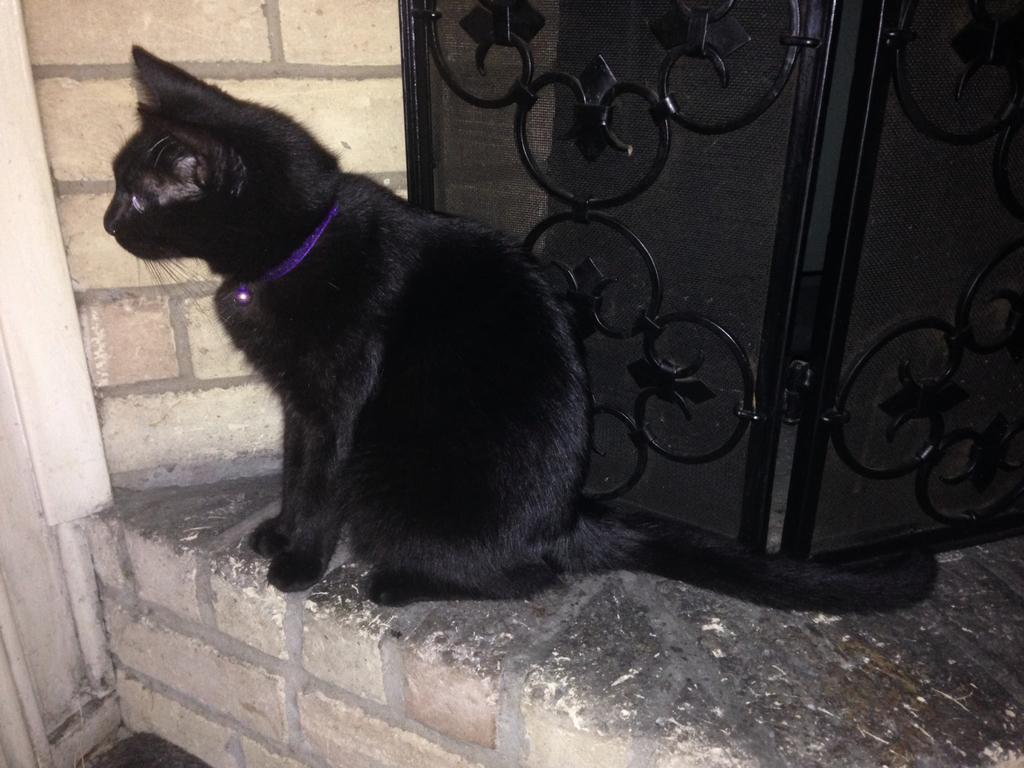What type of animal is on the floor in the image? There is a black cat on the floor. What can be seen on the walls in the image? There are doors visible in the image. What is the background of the image made of? There is a wall in the image. What type of grass is growing on the wall in the image? There is no grass present in the image; it features a black cat on the floor and doors on the wall. 